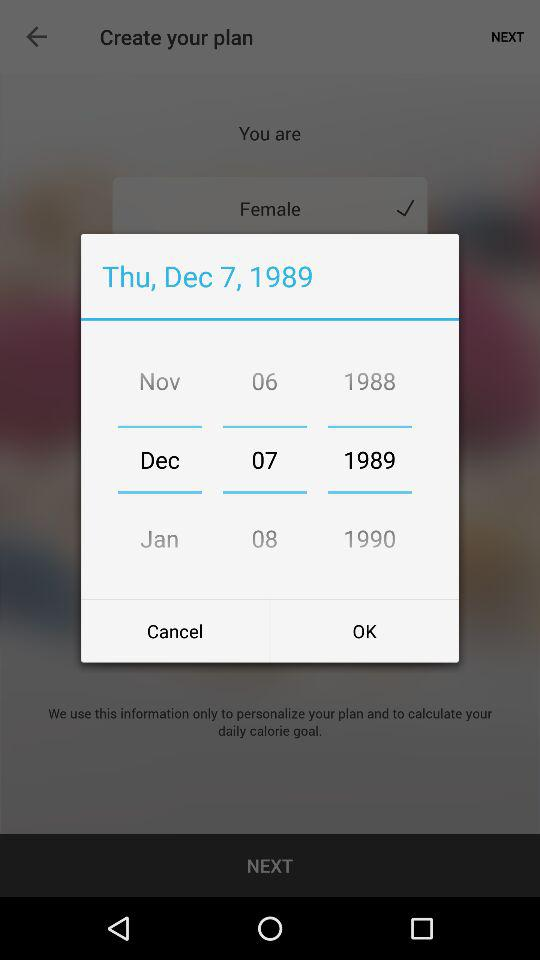How many years are between 1989 and 1990?
Answer the question using a single word or phrase. 1 